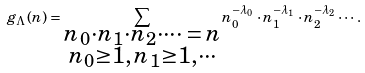Convert formula to latex. <formula><loc_0><loc_0><loc_500><loc_500>g _ { \Lambda } ( n ) = \sum _ { \substack { n _ { 0 } \cdot n _ { 1 } \cdot n _ { 2 } \cdot \cdots \, = \, n \\ n _ { 0 } \geq 1 , \, n _ { 1 } \geq 1 , \cdots } } n _ { 0 } ^ { - \lambda _ { 0 } } \cdot n _ { 1 } ^ { - \lambda _ { 1 } } \cdot n _ { 2 } ^ { - \lambda _ { 2 } } \cdots .</formula> 